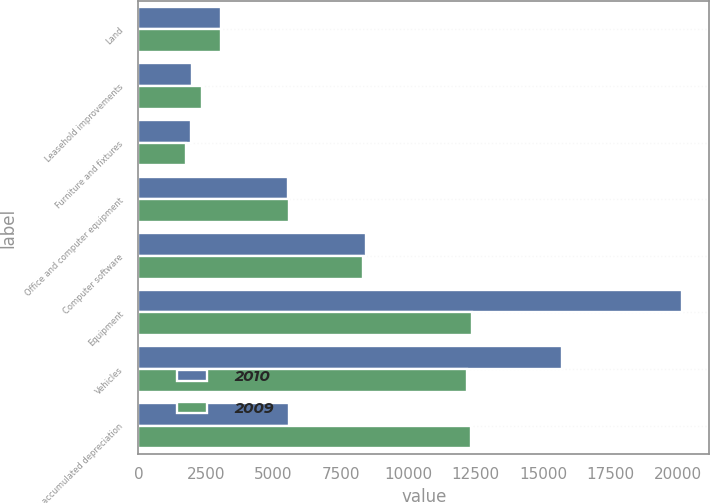<chart> <loc_0><loc_0><loc_500><loc_500><stacked_bar_chart><ecel><fcel>Land<fcel>Leasehold improvements<fcel>Furniture and fixtures<fcel>Office and computer equipment<fcel>Computer software<fcel>Equipment<fcel>Vehicles<fcel>Less accumulated depreciation<nl><fcel>2010<fcel>3076<fcel>1998<fcel>1959<fcel>5541<fcel>8428<fcel>20150<fcel>15696<fcel>5585<nl><fcel>2009<fcel>3076<fcel>2365<fcel>1752<fcel>5585<fcel>8313<fcel>12377<fcel>12170<fcel>12324<nl></chart> 